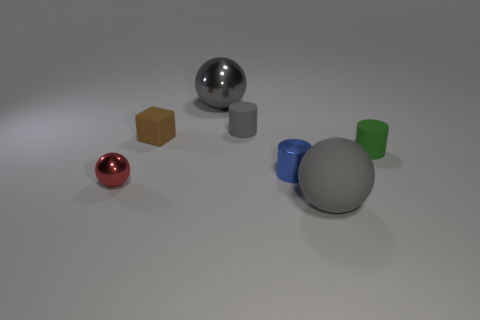There is a small cylinder that is the same color as the matte sphere; what is it made of?
Offer a terse response. Rubber. Is the color of the big metallic object the same as the rubber sphere?
Offer a terse response. Yes. How many brown matte things have the same shape as the small red metal thing?
Keep it short and to the point. 0. The gray ball that is made of the same material as the green thing is what size?
Provide a succinct answer. Large. What color is the tiny matte cylinder to the right of the large gray object in front of the big metal object?
Offer a terse response. Green. There is a tiny green object; is its shape the same as the gray rubber object behind the small green matte cylinder?
Give a very brief answer. Yes. What number of brown cubes are the same size as the gray matte cylinder?
Provide a succinct answer. 1. There is a small gray thing that is the same shape as the green matte thing; what material is it?
Offer a terse response. Rubber. There is a ball that is to the right of the small blue object; is it the same color as the large thing that is behind the small red thing?
Provide a succinct answer. Yes. There is a big gray object behind the blue cylinder; what shape is it?
Your response must be concise. Sphere. 